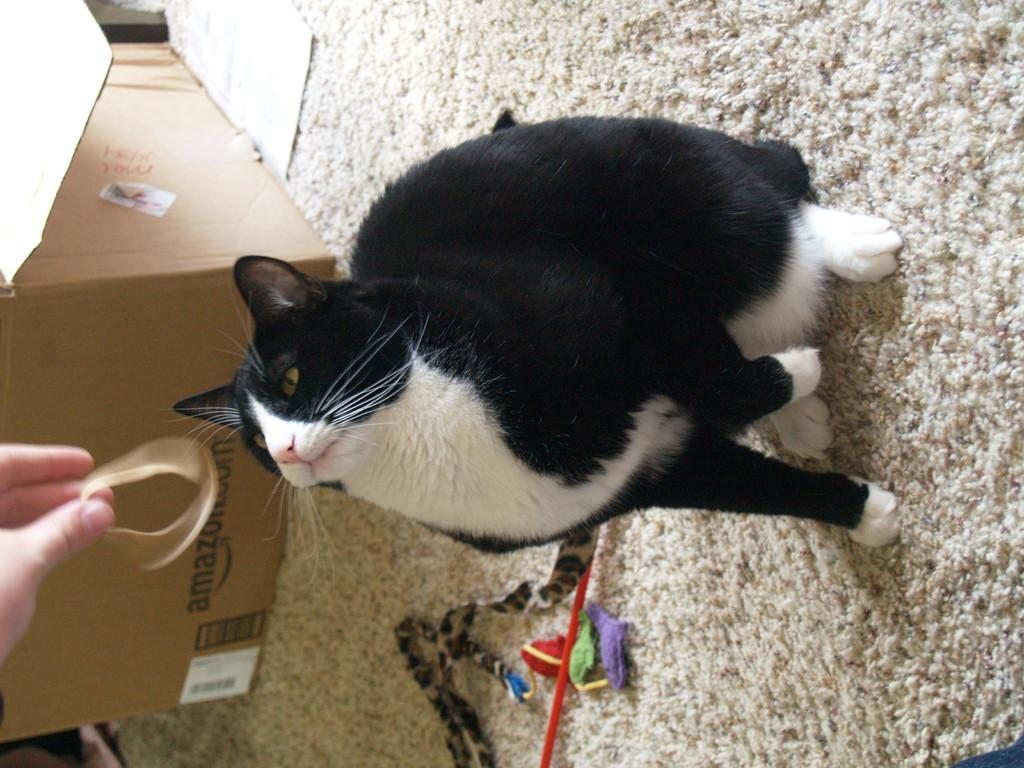What is on the floor in the image? There is a carpet on the floor in the image. What is the ribbon used for in the image? The ribbon is being held by a hand in the image. What type of visual content is present in the image? There is a cartoon in the image. What animal can be seen sitting on the floor in the image? A cat is sitting on the floor in the image. What day of the week is depicted on the calendar in the image? There is no calendar present in the image. What time of day is it in the image? The provided facts do not give any information about the time of day. 